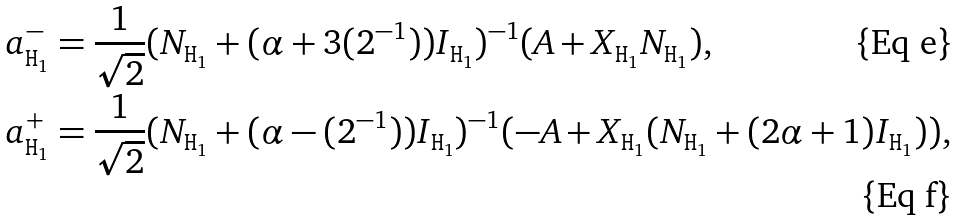<formula> <loc_0><loc_0><loc_500><loc_500>a ^ { - } _ { { \tt H } _ { 1 } } & = { \frac { 1 } { \sqrt { 2 } } } ( N _ { { \tt H } _ { 1 } } + ( \alpha + 3 { ( 2 ^ { - 1 } ) ) { I _ { { \tt H } _ { 1 } } } } ) ^ { - 1 } ( A + X _ { { \tt H } _ { 1 } } N _ { { \tt H } _ { 1 } } ) , \\ a ^ { + } _ { { \tt H } _ { 1 } } & = { \frac { 1 } { \sqrt { 2 } } } ( N _ { { \tt H } _ { 1 } } + ( \alpha - { ( 2 ^ { - 1 } ) ) { I _ { { \tt H } _ { 1 } } } } ) ^ { - 1 } ( - A + X _ { { \tt H } _ { 1 } } ( N _ { { \tt H } _ { 1 } } + ( 2 \alpha + 1 ) I _ { { \tt H } _ { 1 } } ) ) ,</formula> 